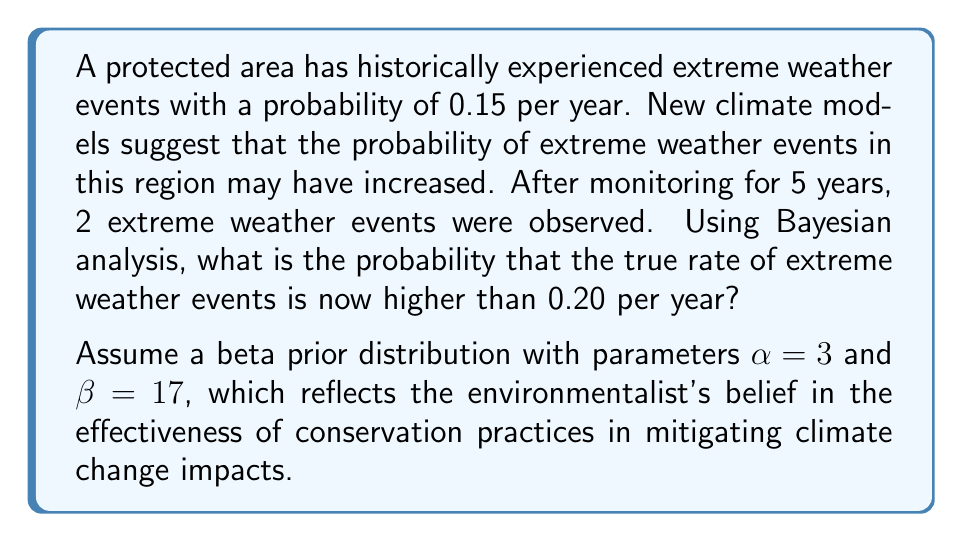Help me with this question. To solve this problem using Bayesian analysis, we'll follow these steps:

1) First, we need to define our prior distribution. We're given a beta prior with $\alpha = 3$ and $\beta = 17$. This reflects our initial belief about the probability of extreme weather events.

2) We then update this prior with our observed data (2 events in 5 years) to get our posterior distribution. The posterior distribution will also be a beta distribution with parameters:

   $\alpha_{posterior} = \alpha_{prior} + \text{number of successes} = 3 + 2 = 5$
   $\beta_{posterior} = \beta_{prior} + \text{number of failures} = 17 + (5-2) = 20$

3) Now, we need to calculate the probability that the true rate is higher than 0.20. This is equivalent to finding the area under the posterior beta distribution curve from 0.20 to 1.

4) The cumulative distribution function (CDF) of the beta distribution is given by the regularized incomplete beta function. We need to calculate:

   $P(\theta > 0.20) = 1 - I_{0.20}(5, 20)$

   Where $I_x(a,b)$ is the regularized incomplete beta function.

5) Using a statistical calculator or software, we can compute this value:

   $1 - I_{0.20}(5, 20) \approx 0.2835$

Therefore, based on our prior beliefs and the observed data, there is approximately a 28.35% chance that the true rate of extreme weather events is now higher than 0.20 per year.
Answer: 0.2835 or 28.35% 